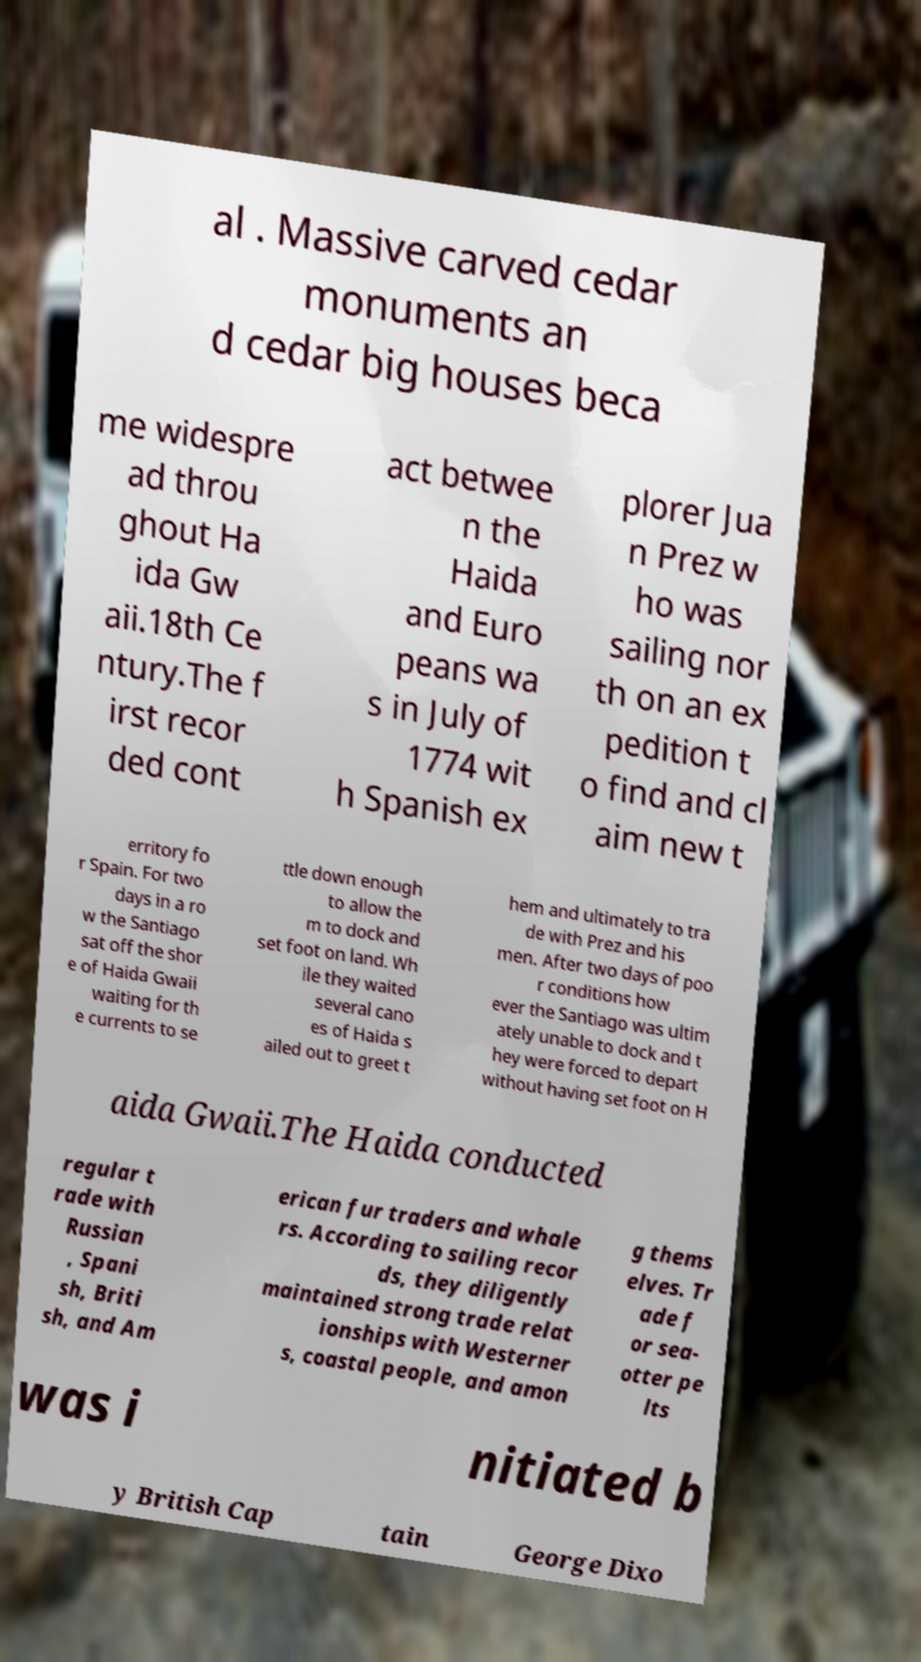Could you extract and type out the text from this image? al . Massive carved cedar monuments an d cedar big houses beca me widespre ad throu ghout Ha ida Gw aii.18th Ce ntury.The f irst recor ded cont act betwee n the Haida and Euro peans wa s in July of 1774 wit h Spanish ex plorer Jua n Prez w ho was sailing nor th on an ex pedition t o find and cl aim new t erritory fo r Spain. For two days in a ro w the Santiago sat off the shor e of Haida Gwaii waiting for th e currents to se ttle down enough to allow the m to dock and set foot on land. Wh ile they waited several cano es of Haida s ailed out to greet t hem and ultimately to tra de with Prez and his men. After two days of poo r conditions how ever the Santiago was ultim ately unable to dock and t hey were forced to depart without having set foot on H aida Gwaii.The Haida conducted regular t rade with Russian , Spani sh, Briti sh, and Am erican fur traders and whale rs. According to sailing recor ds, they diligently maintained strong trade relat ionships with Westerner s, coastal people, and amon g thems elves. Tr ade f or sea- otter pe lts was i nitiated b y British Cap tain George Dixo 